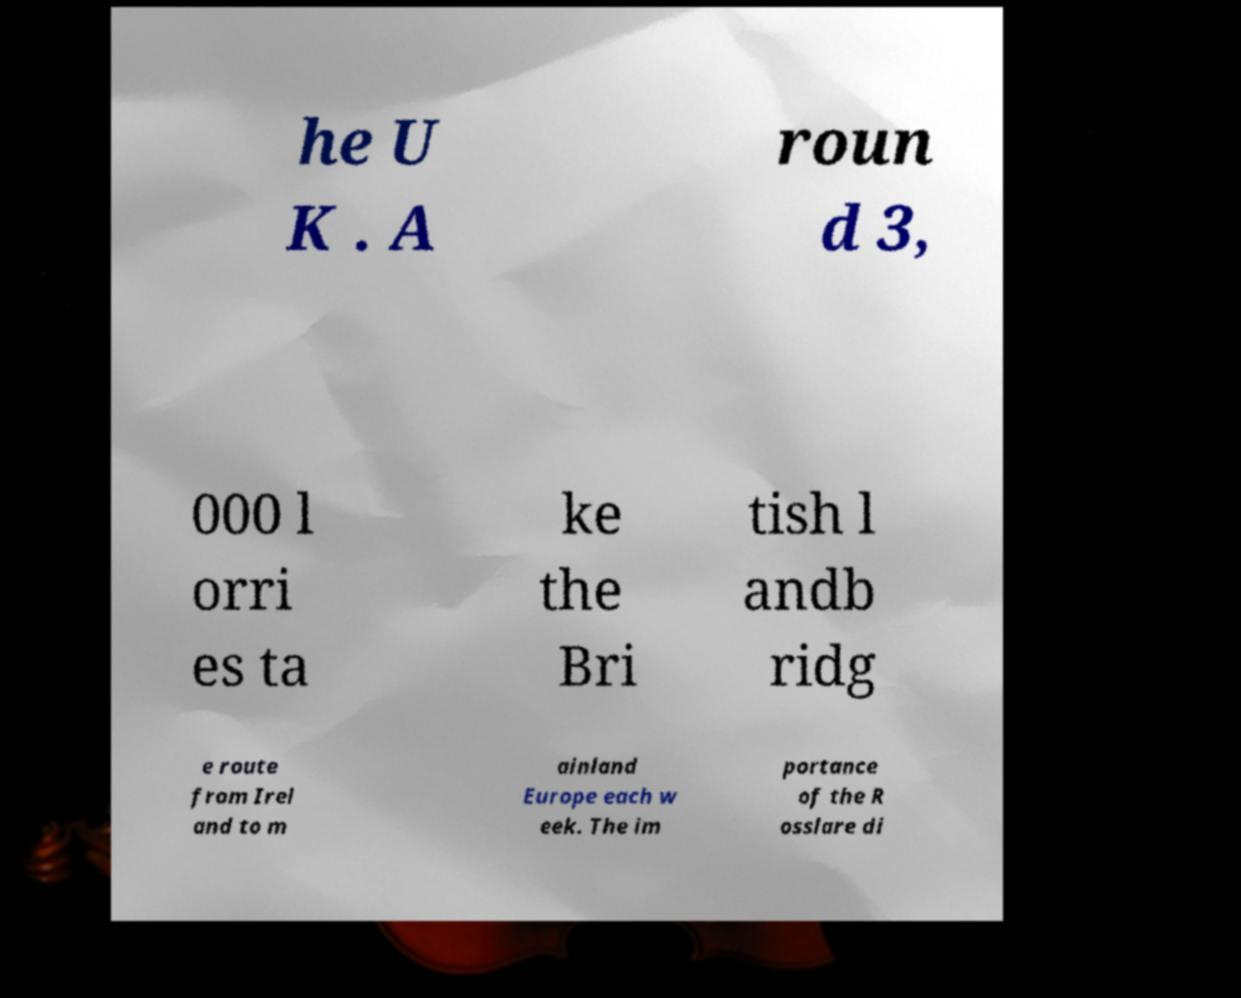Please identify and transcribe the text found in this image. he U K . A roun d 3, 000 l orri es ta ke the Bri tish l andb ridg e route from Irel and to m ainland Europe each w eek. The im portance of the R osslare di 